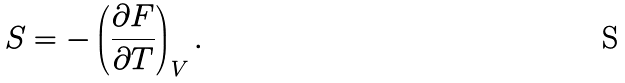<formula> <loc_0><loc_0><loc_500><loc_500>S = - \left ( \frac { \partial F } { \partial T } \right ) _ { V } .</formula> 